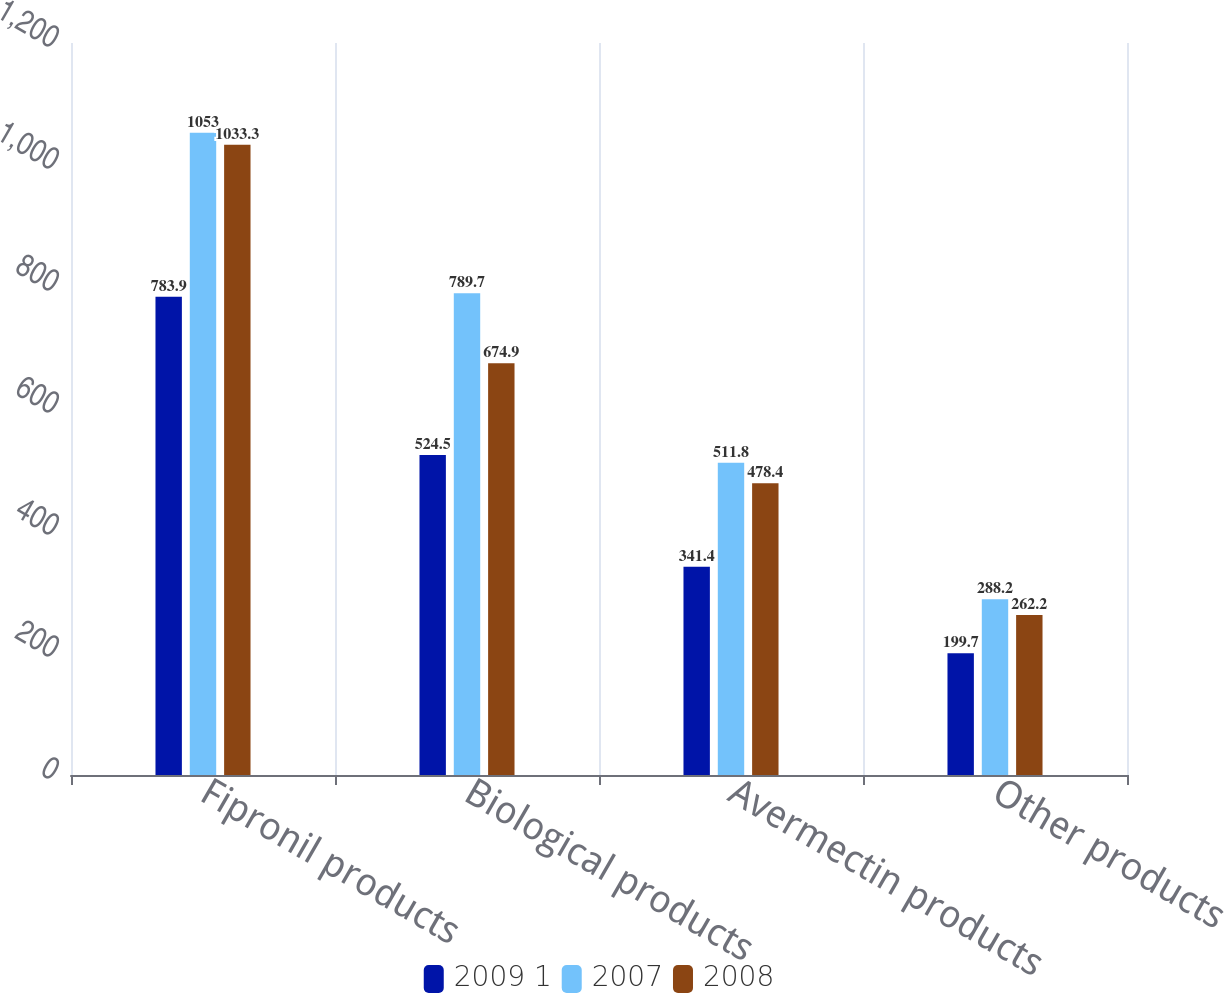Convert chart to OTSL. <chart><loc_0><loc_0><loc_500><loc_500><stacked_bar_chart><ecel><fcel>Fipronil products<fcel>Biological products<fcel>Avermectin products<fcel>Other products<nl><fcel>2009 1<fcel>783.9<fcel>524.5<fcel>341.4<fcel>199.7<nl><fcel>2007<fcel>1053<fcel>789.7<fcel>511.8<fcel>288.2<nl><fcel>2008<fcel>1033.3<fcel>674.9<fcel>478.4<fcel>262.2<nl></chart> 